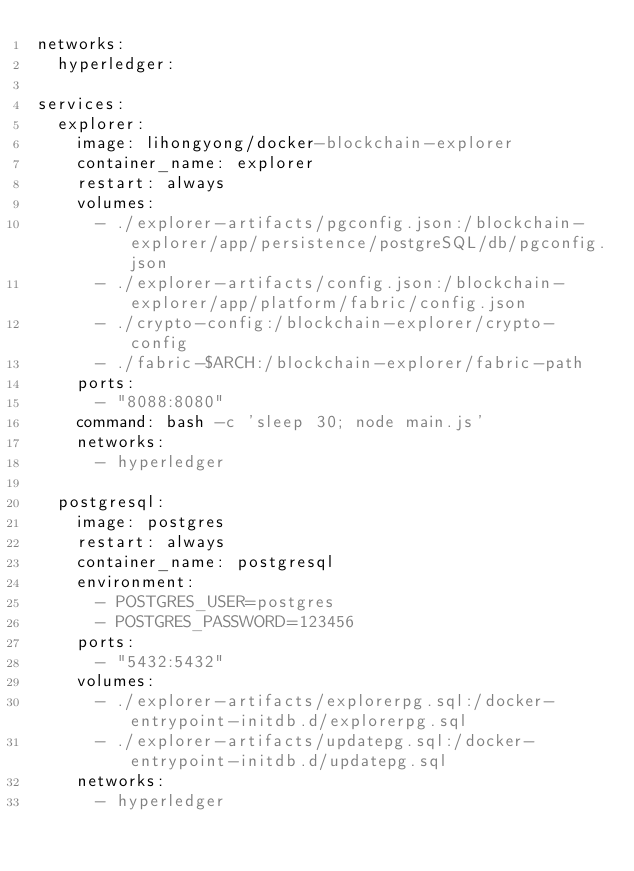Convert code to text. <code><loc_0><loc_0><loc_500><loc_500><_YAML_>networks:
  hyperledger:

services:
  explorer:
    image: lihongyong/docker-blockchain-explorer
    container_name: explorer
    restart: always
    volumes:
      - ./explorer-artifacts/pgconfig.json:/blockchain-explorer/app/persistence/postgreSQL/db/pgconfig.json
      - ./explorer-artifacts/config.json:/blockchain-explorer/app/platform/fabric/config.json
      - ./crypto-config:/blockchain-explorer/crypto-config
      - ./fabric-$ARCH:/blockchain-explorer/fabric-path
    ports:
      - "8088:8080"
    command: bash -c 'sleep 30; node main.js'
    networks:
      - hyperledger
      
  postgresql:
    image: postgres
    restart: always
    container_name: postgresql
    environment:
      - POSTGRES_USER=postgres
      - POSTGRES_PASSWORD=123456
    ports:
      - "5432:5432"
    volumes:
      - ./explorer-artifacts/explorerpg.sql:/docker-entrypoint-initdb.d/explorerpg.sql
      - ./explorer-artifacts/updatepg.sql:/docker-entrypoint-initdb.d/updatepg.sql
    networks:
      - hyperledger</code> 